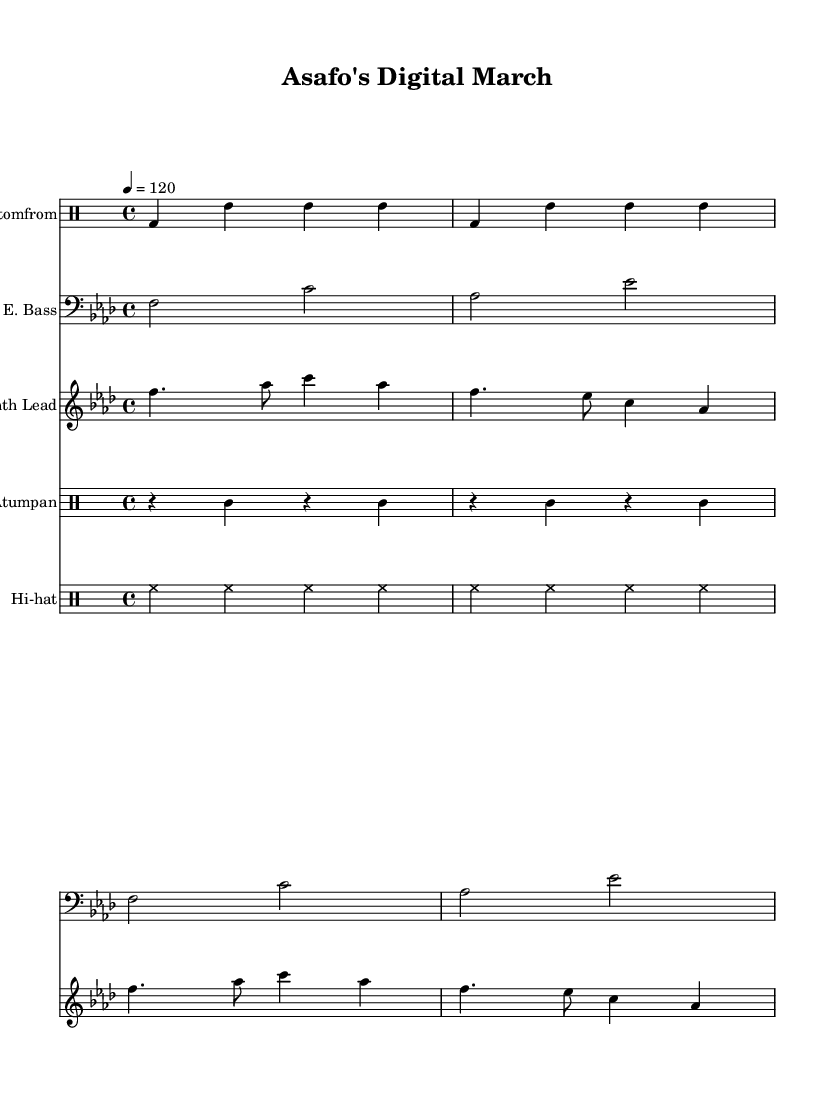What is the key signature of this music? The key signature is F minor, which has four flats (B♭, E♭, A♭, and D♭). This is determined by the presence of the flat sign on the staff at the beginning of the score.
Answer: F minor What is the time signature of this music? The time signature displayed at the beginning indicates 4/4 time, meaning there are four beats in each measure and the quarter note receives one beat. This can be identified by the numbers found after the key signature on the score.
Answer: 4/4 What is the tempo marking for this piece? The tempo marking states 4 = 120, indicating that there are 120 beats per minute, with a quarter note being one beat. This is typically placed above the staff but is relevant for all instruments in the score.
Answer: 120 How many different instruments are there in this score? The score features five distinct instruments: Fontomfrom, E. Bass, Synth Lead, Atumpan, and Hi-hat. Each is represented in separate staves throughout the score, indicating multiple layers of sound and instrumentation.
Answer: 5 Which traditional Ghanaian drum is used in this piece? The piece includes the Atumpan, a traditional drum used in Ghanaian music. It is specifically noted in the drumming sections of the score where the Atumpan pattern is indicated, showcasing its cultural significance.
Answer: Atumpan What type of fusion is represented in this music? The music is characterized as "Electronic fusion incorporating traditional Ghanaian war drums and modern beats," combining these elements creatively. This can be inferred from the blending of traditional drum patterns with electronic sounds and rhythms throughout the score.
Answer: Electronic fusion 